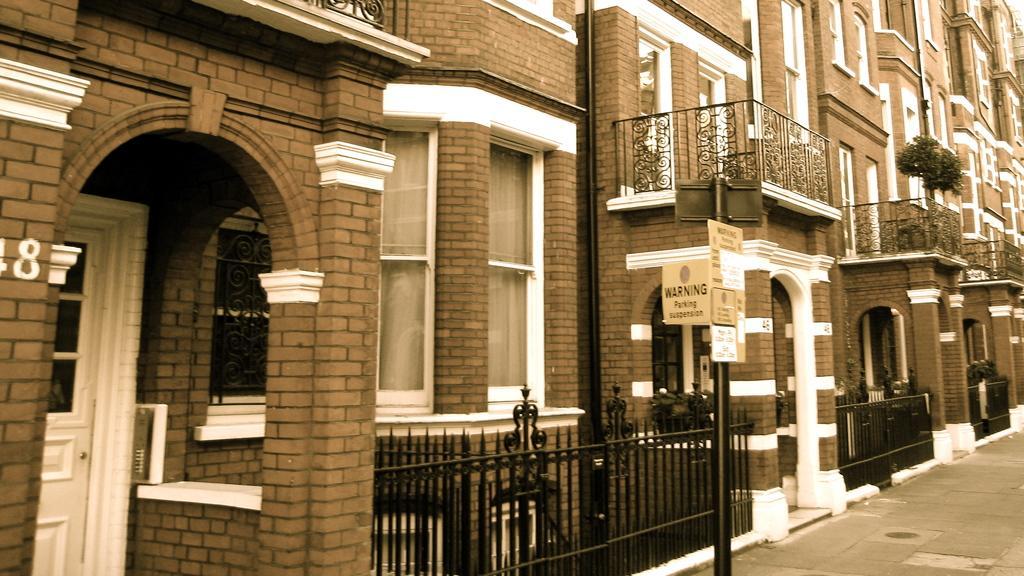How would you summarize this image in a sentence or two? Here we can see buildings,doors,windows,fences,a pole and boards attached to it,house plants and road. 